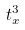Convert formula to latex. <formula><loc_0><loc_0><loc_500><loc_500>t _ { x } ^ { 3 }</formula> 